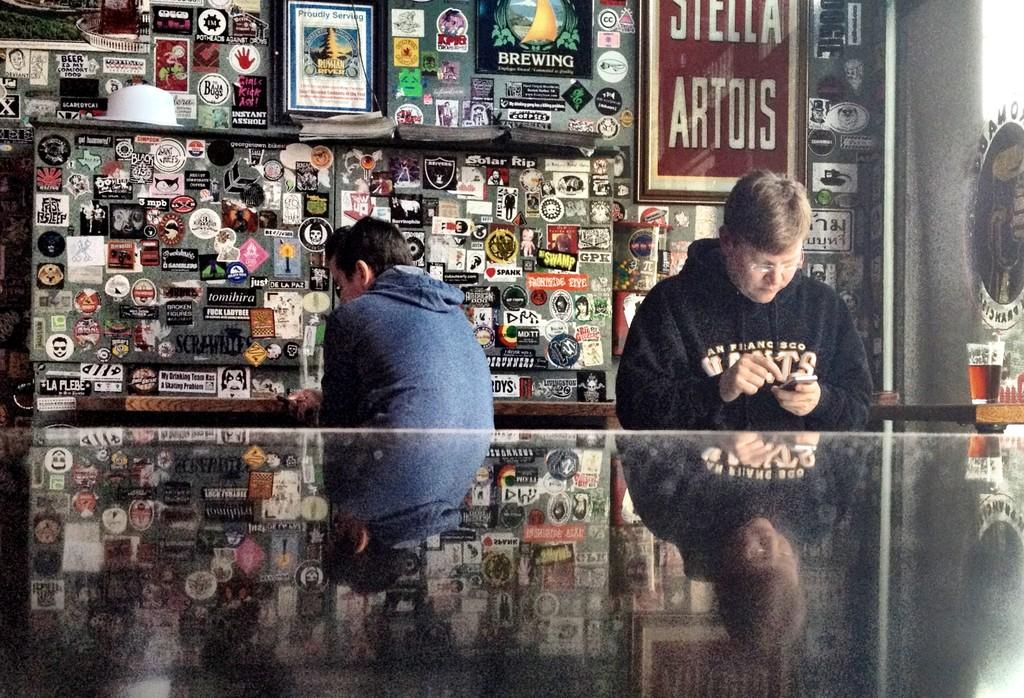How many people are in the image? There are two men in the image. What are the men doing in the image? The men are sitting. What are the men holding in their hands? The men are holding mobiles in their hands. What can be seen on the wall in the background? There are photo frames and other objects attached to the wall in the background. What type of basketball game is being played in the image? There is no basketball game present in the image. How does the screw help in the image? There is no screw present in the image. 